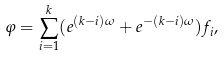<formula> <loc_0><loc_0><loc_500><loc_500>\varphi = \sum _ { i = 1 } ^ { k } ( e ^ { ( k - i ) \omega } + e ^ { - ( k - i ) \omega } ) f _ { i } ,</formula> 